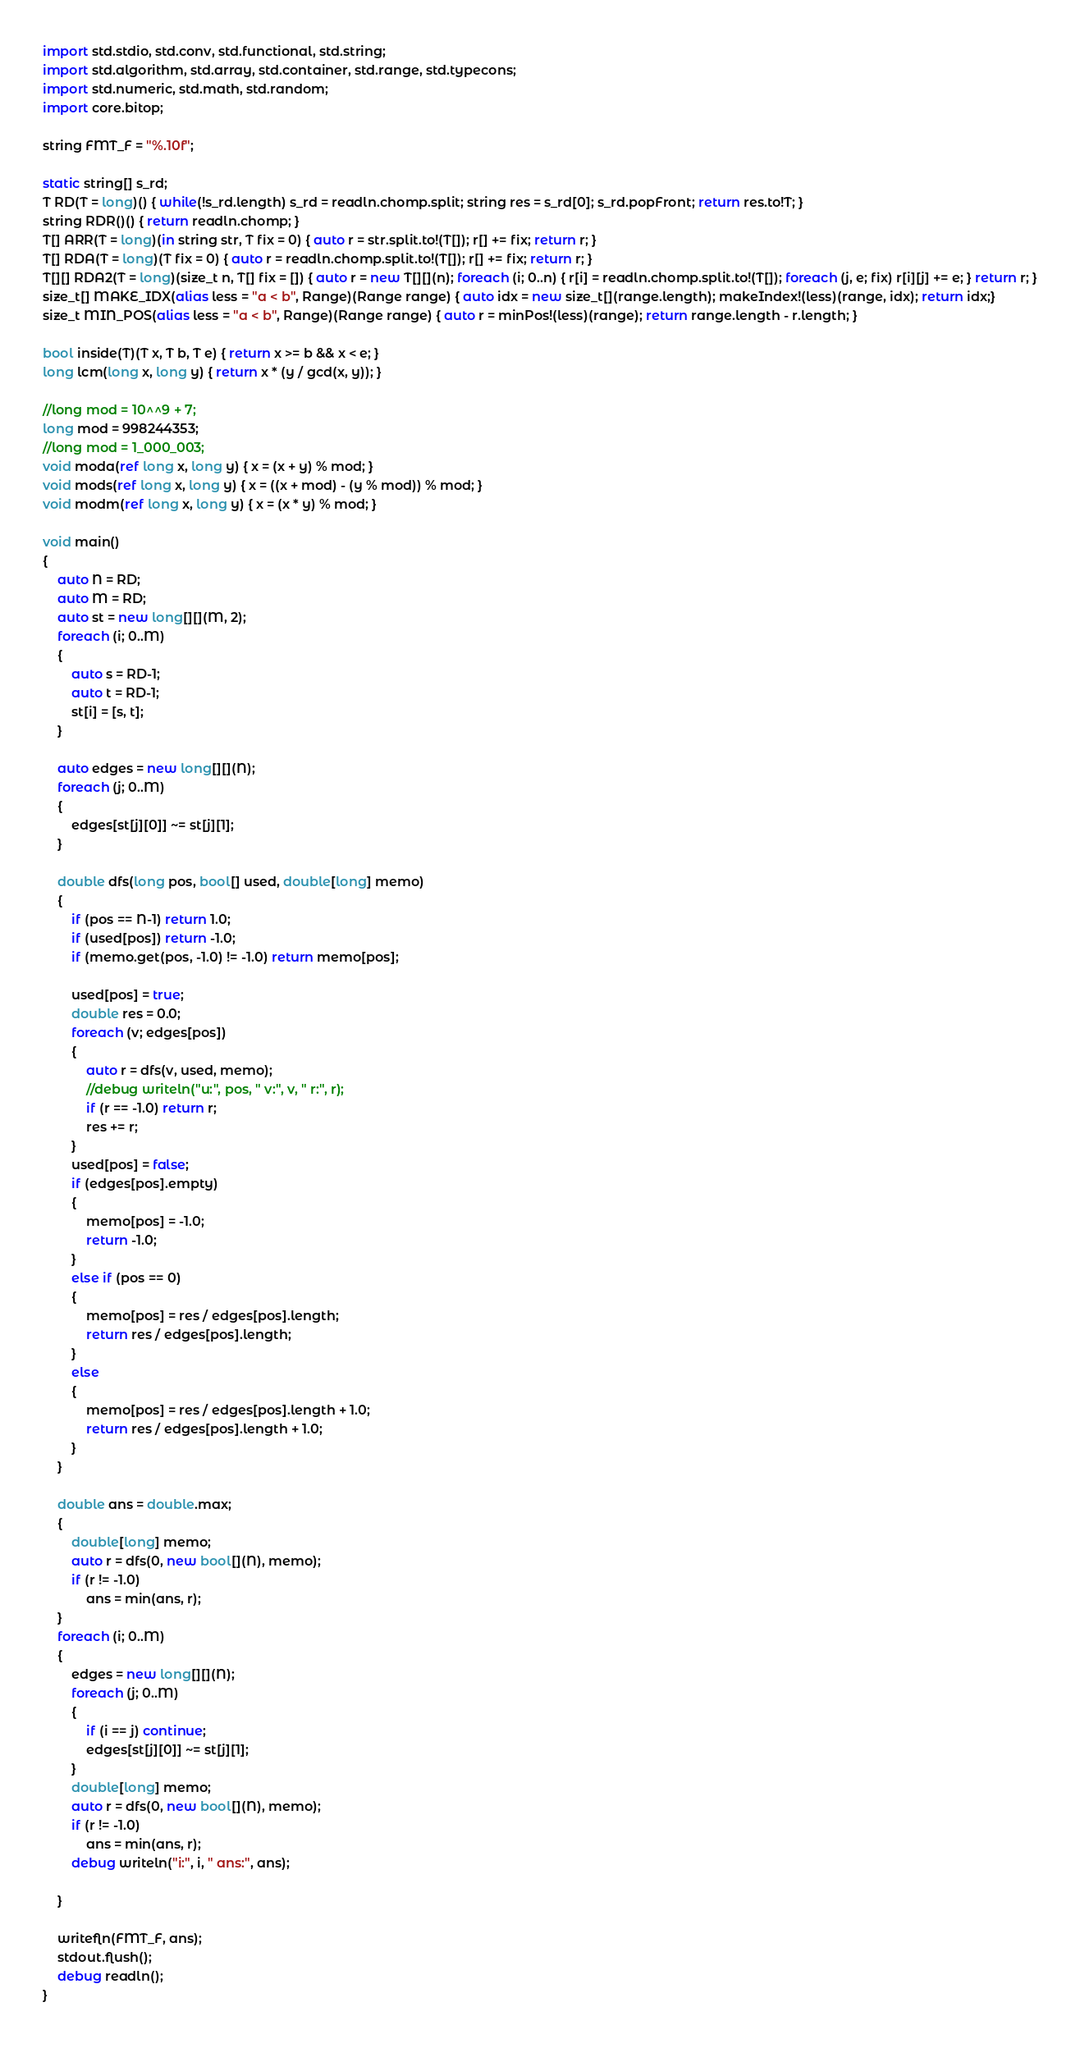<code> <loc_0><loc_0><loc_500><loc_500><_D_>import std.stdio, std.conv, std.functional, std.string;
import std.algorithm, std.array, std.container, std.range, std.typecons;
import std.numeric, std.math, std.random;
import core.bitop;

string FMT_F = "%.10f";

static string[] s_rd;
T RD(T = long)() { while(!s_rd.length) s_rd = readln.chomp.split; string res = s_rd[0]; s_rd.popFront; return res.to!T; }
string RDR()() { return readln.chomp; }
T[] ARR(T = long)(in string str, T fix = 0) { auto r = str.split.to!(T[]); r[] += fix; return r; }
T[] RDA(T = long)(T fix = 0) { auto r = readln.chomp.split.to!(T[]); r[] += fix; return r; }
T[][] RDA2(T = long)(size_t n, T[] fix = []) { auto r = new T[][](n); foreach (i; 0..n) { r[i] = readln.chomp.split.to!(T[]); foreach (j, e; fix) r[i][j] += e; } return r; }
size_t[] MAKE_IDX(alias less = "a < b", Range)(Range range) { auto idx = new size_t[](range.length); makeIndex!(less)(range, idx); return idx;}
size_t MIN_POS(alias less = "a < b", Range)(Range range) { auto r = minPos!(less)(range); return range.length - r.length; }

bool inside(T)(T x, T b, T e) { return x >= b && x < e; }
long lcm(long x, long y) { return x * (y / gcd(x, y)); }

//long mod = 10^^9 + 7;
long mod = 998244353;
//long mod = 1_000_003;
void moda(ref long x, long y) { x = (x + y) % mod; }
void mods(ref long x, long y) { x = ((x + mod) - (y % mod)) % mod; }
void modm(ref long x, long y) { x = (x * y) % mod; }

void main()
{
	auto N = RD;
	auto M = RD;
	auto st = new long[][](M, 2);
	foreach (i; 0..M)
	{
		auto s = RD-1;
		auto t = RD-1;
		st[i] = [s, t];
	}

	auto edges = new long[][](N);
	foreach (j; 0..M)
	{
		edges[st[j][0]] ~= st[j][1];
	}

	double dfs(long pos, bool[] used, double[long] memo)
	{
		if (pos == N-1) return 1.0;
		if (used[pos]) return -1.0;
		if (memo.get(pos, -1.0) != -1.0) return memo[pos];

		used[pos] = true;
		double res = 0.0;
		foreach (v; edges[pos])
		{
			auto r = dfs(v, used, memo);
			//debug writeln("u:", pos, " v:", v, " r:", r);
			if (r == -1.0) return r;
			res += r;
		}
		used[pos] = false;
		if (edges[pos].empty)
		{
			memo[pos] = -1.0;
			return -1.0;
		}
		else if (pos == 0)
		{
			memo[pos] = res / edges[pos].length;
			return res / edges[pos].length;
		}
		else
		{
			memo[pos] = res / edges[pos].length + 1.0;
			return res / edges[pos].length + 1.0;
		}
	}

	double ans = double.max;
	{
		double[long] memo;
		auto r = dfs(0, new bool[](N), memo);
		if (r != -1.0)
			ans = min(ans, r);
	}
	foreach (i; 0..M)
	{
		edges = new long[][](N);
		foreach (j; 0..M)
		{
			if (i == j) continue;
			edges[st[j][0]] ~= st[j][1];
		}
		double[long] memo;
		auto r = dfs(0, new bool[](N), memo);
		if (r != -1.0)
			ans = min(ans, r);
		debug writeln("i:", i, " ans:", ans);

	}
	
	writefln(FMT_F, ans);
	stdout.flush();
	debug readln();
}</code> 